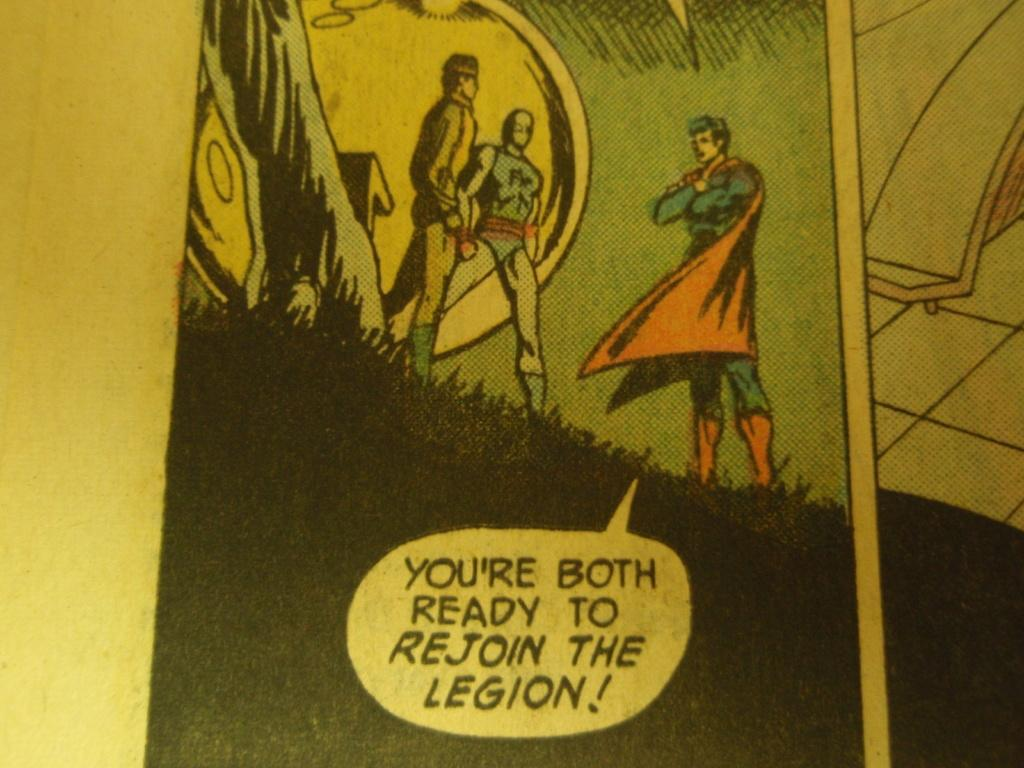<image>
Describe the image concisely. A superman comic where superman asks if others are ready to join 